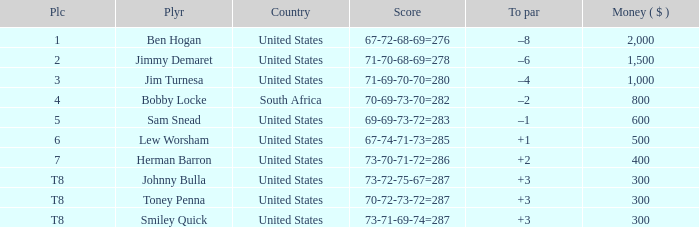What is the Place of the Player with a To par of –1? 5.0. 